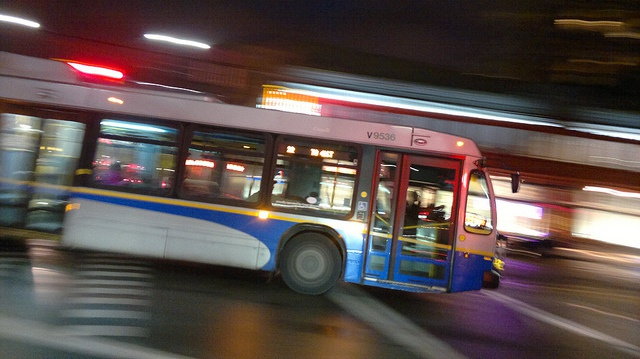Describe the objects in this image and their specific colors. I can see bus in black, darkgray, gray, and maroon tones, people in black, maroon, and gray tones, people in black, purple, and gray tones, and people in darkgreen, gray, and black tones in this image. 